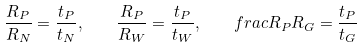Convert formula to latex. <formula><loc_0><loc_0><loc_500><loc_500>\frac { R _ { P } } { R _ { N } } = \frac { t _ { P } } { t _ { N } } , \quad \frac { R _ { P } } { R _ { W } } = \frac { t _ { P } } { t _ { W } } , \quad f r a c { R _ { P } } { R _ { G } } = \frac { t _ { P } } { t _ { G } }</formula> 